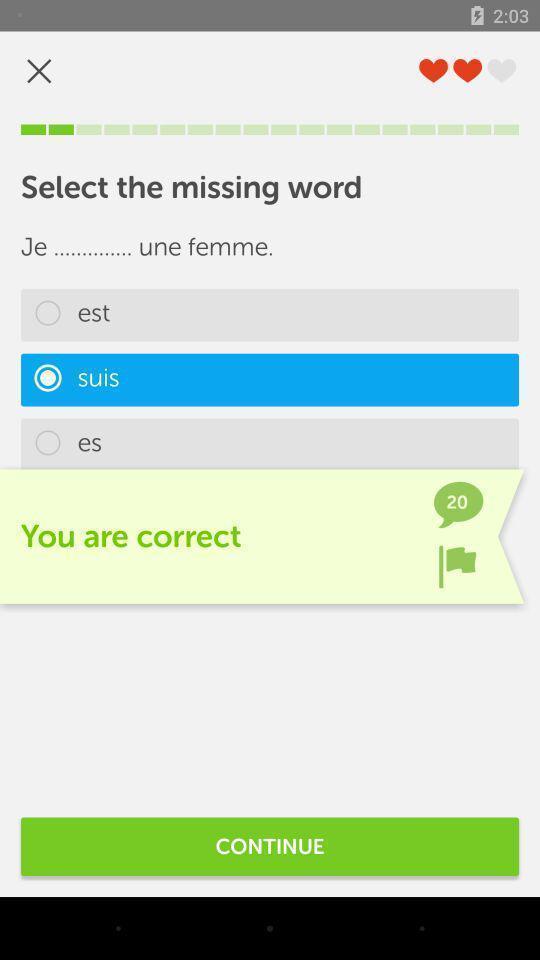What can you discern from this picture? Page to select the missing words for learning app. 